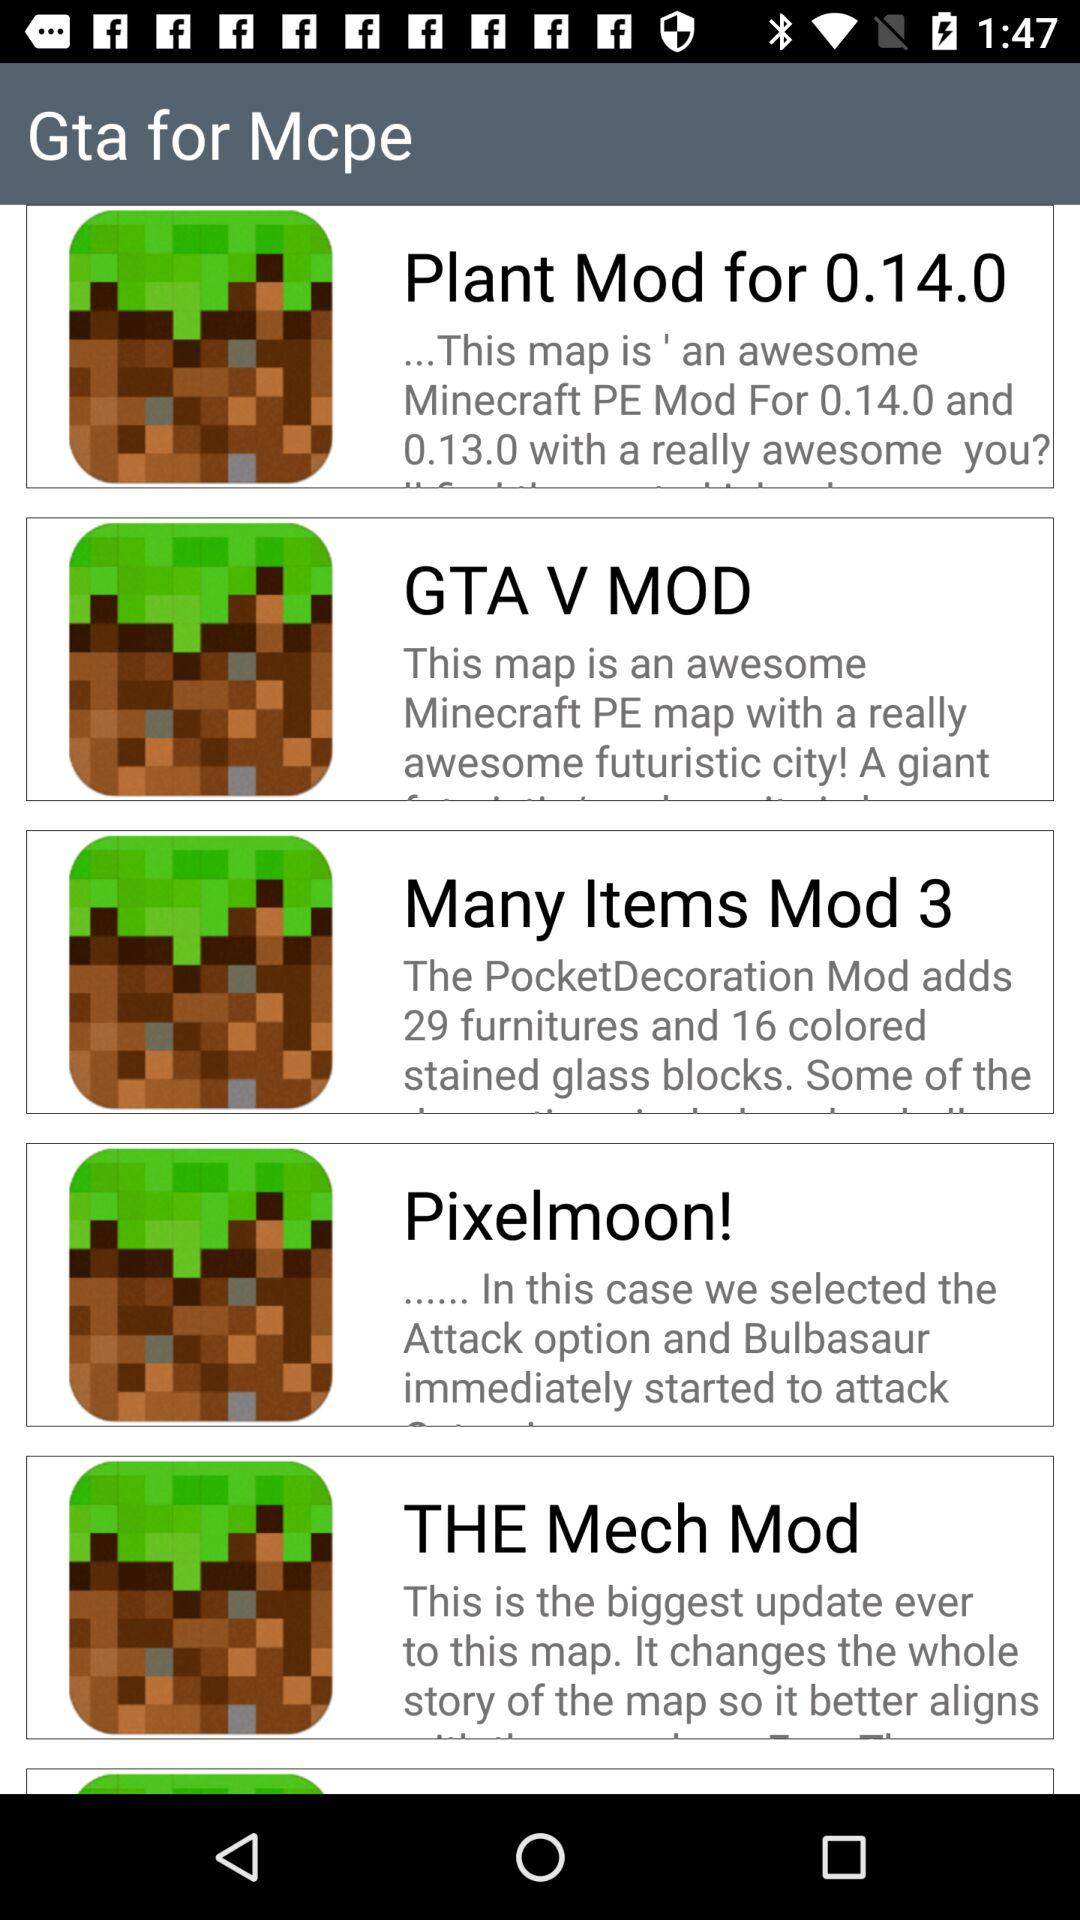What is the name of the application? The names of the applications are "Gta for Mcpe", "Plant Mod for 0.14.0", "GTA V MOD", "Many Items Mod 3", "Pixelmoon!" and "THE Mech Mod". 